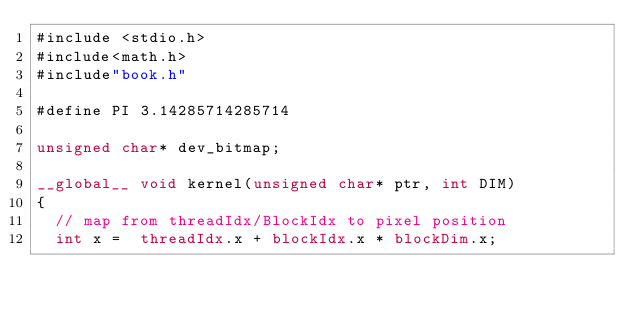<code> <loc_0><loc_0><loc_500><loc_500><_Cuda_>#include <stdio.h>
#include<math.h>
#include"book.h"

#define PI 3.14285714285714

unsigned char* dev_bitmap;

__global__ void kernel(unsigned char* ptr, int DIM)
{
	// map from threadIdx/BlockIdx to pixel position
	int x =  threadIdx.x + blockIdx.x * blockDim.x;</code> 